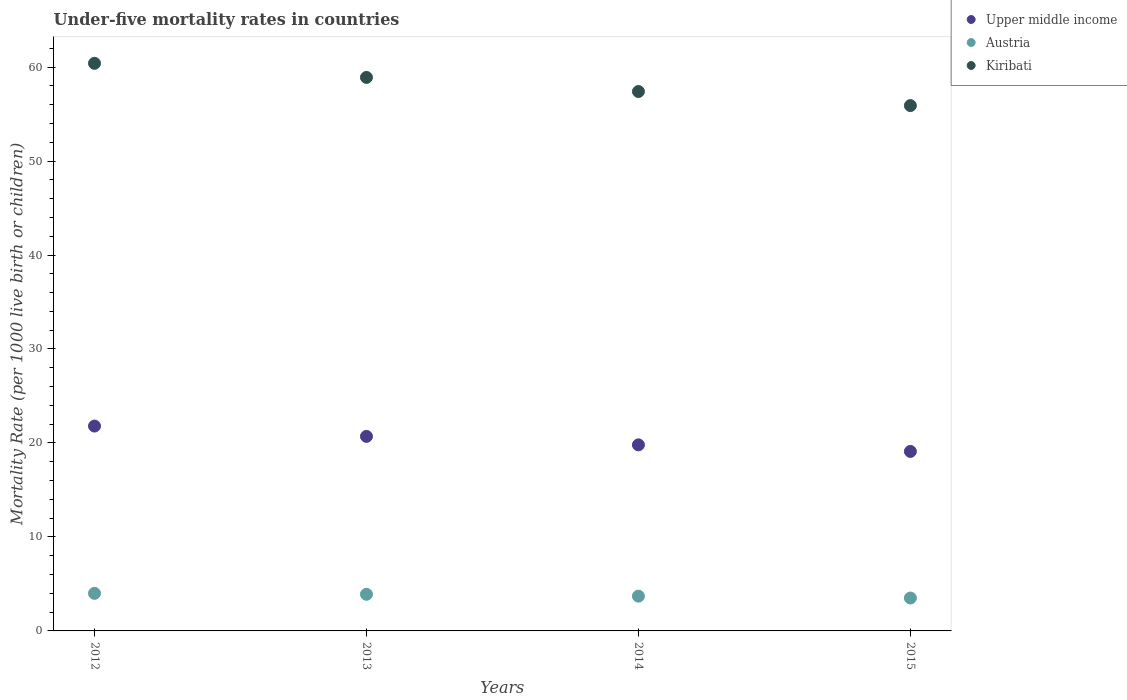How many different coloured dotlines are there?
Your answer should be very brief. 3. In which year was the under-five mortality rate in Kiribati maximum?
Provide a succinct answer. 2012. In which year was the under-five mortality rate in Austria minimum?
Your answer should be very brief. 2015. What is the total under-five mortality rate in Austria in the graph?
Your response must be concise. 15.1. What is the difference between the under-five mortality rate in Austria in 2013 and that in 2014?
Make the answer very short. 0.2. What is the difference between the under-five mortality rate in Austria in 2015 and the under-five mortality rate in Upper middle income in 2012?
Give a very brief answer. -18.3. What is the average under-five mortality rate in Upper middle income per year?
Your answer should be very brief. 20.35. In the year 2013, what is the difference between the under-five mortality rate in Upper middle income and under-five mortality rate in Kiribati?
Keep it short and to the point. -38.2. What is the ratio of the under-five mortality rate in Kiribati in 2013 to that in 2015?
Your answer should be very brief. 1.05. Is the difference between the under-five mortality rate in Upper middle income in 2014 and 2015 greater than the difference between the under-five mortality rate in Kiribati in 2014 and 2015?
Offer a very short reply. No. What is the difference between the highest and the second highest under-five mortality rate in Upper middle income?
Your response must be concise. 1.1. What is the difference between the highest and the lowest under-five mortality rate in Kiribati?
Your response must be concise. 4.5. Is the sum of the under-five mortality rate in Austria in 2014 and 2015 greater than the maximum under-five mortality rate in Kiribati across all years?
Your answer should be very brief. No. Does the under-five mortality rate in Austria monotonically increase over the years?
Your answer should be very brief. No. How many dotlines are there?
Your answer should be very brief. 3. What is the difference between two consecutive major ticks on the Y-axis?
Provide a succinct answer. 10. Are the values on the major ticks of Y-axis written in scientific E-notation?
Offer a terse response. No. Does the graph contain grids?
Give a very brief answer. No. Where does the legend appear in the graph?
Your response must be concise. Top right. How many legend labels are there?
Your response must be concise. 3. How are the legend labels stacked?
Give a very brief answer. Vertical. What is the title of the graph?
Offer a terse response. Under-five mortality rates in countries. What is the label or title of the Y-axis?
Your response must be concise. Mortality Rate (per 1000 live birth or children). What is the Mortality Rate (per 1000 live birth or children) in Upper middle income in 2012?
Offer a very short reply. 21.8. What is the Mortality Rate (per 1000 live birth or children) in Austria in 2012?
Your answer should be compact. 4. What is the Mortality Rate (per 1000 live birth or children) of Kiribati in 2012?
Provide a short and direct response. 60.4. What is the Mortality Rate (per 1000 live birth or children) in Upper middle income in 2013?
Provide a short and direct response. 20.7. What is the Mortality Rate (per 1000 live birth or children) of Kiribati in 2013?
Offer a very short reply. 58.9. What is the Mortality Rate (per 1000 live birth or children) of Upper middle income in 2014?
Ensure brevity in your answer.  19.8. What is the Mortality Rate (per 1000 live birth or children) in Kiribati in 2014?
Your response must be concise. 57.4. What is the Mortality Rate (per 1000 live birth or children) in Upper middle income in 2015?
Your response must be concise. 19.1. What is the Mortality Rate (per 1000 live birth or children) of Austria in 2015?
Give a very brief answer. 3.5. What is the Mortality Rate (per 1000 live birth or children) of Kiribati in 2015?
Offer a terse response. 55.9. Across all years, what is the maximum Mortality Rate (per 1000 live birth or children) in Upper middle income?
Keep it short and to the point. 21.8. Across all years, what is the maximum Mortality Rate (per 1000 live birth or children) of Austria?
Keep it short and to the point. 4. Across all years, what is the maximum Mortality Rate (per 1000 live birth or children) of Kiribati?
Keep it short and to the point. 60.4. Across all years, what is the minimum Mortality Rate (per 1000 live birth or children) in Austria?
Offer a very short reply. 3.5. Across all years, what is the minimum Mortality Rate (per 1000 live birth or children) in Kiribati?
Your answer should be compact. 55.9. What is the total Mortality Rate (per 1000 live birth or children) in Upper middle income in the graph?
Keep it short and to the point. 81.4. What is the total Mortality Rate (per 1000 live birth or children) of Kiribati in the graph?
Offer a terse response. 232.6. What is the difference between the Mortality Rate (per 1000 live birth or children) in Austria in 2012 and that in 2013?
Provide a succinct answer. 0.1. What is the difference between the Mortality Rate (per 1000 live birth or children) in Kiribati in 2012 and that in 2013?
Your answer should be very brief. 1.5. What is the difference between the Mortality Rate (per 1000 live birth or children) of Upper middle income in 2012 and that in 2014?
Your answer should be very brief. 2. What is the difference between the Mortality Rate (per 1000 live birth or children) in Austria in 2012 and that in 2014?
Provide a short and direct response. 0.3. What is the difference between the Mortality Rate (per 1000 live birth or children) of Kiribati in 2012 and that in 2014?
Ensure brevity in your answer.  3. What is the difference between the Mortality Rate (per 1000 live birth or children) of Upper middle income in 2012 and that in 2015?
Keep it short and to the point. 2.7. What is the difference between the Mortality Rate (per 1000 live birth or children) in Upper middle income in 2013 and that in 2014?
Provide a short and direct response. 0.9. What is the difference between the Mortality Rate (per 1000 live birth or children) in Austria in 2013 and that in 2014?
Make the answer very short. 0.2. What is the difference between the Mortality Rate (per 1000 live birth or children) of Upper middle income in 2013 and that in 2015?
Your answer should be very brief. 1.6. What is the difference between the Mortality Rate (per 1000 live birth or children) in Upper middle income in 2012 and the Mortality Rate (per 1000 live birth or children) in Kiribati in 2013?
Ensure brevity in your answer.  -37.1. What is the difference between the Mortality Rate (per 1000 live birth or children) of Austria in 2012 and the Mortality Rate (per 1000 live birth or children) of Kiribati in 2013?
Your answer should be compact. -54.9. What is the difference between the Mortality Rate (per 1000 live birth or children) in Upper middle income in 2012 and the Mortality Rate (per 1000 live birth or children) in Austria in 2014?
Provide a succinct answer. 18.1. What is the difference between the Mortality Rate (per 1000 live birth or children) of Upper middle income in 2012 and the Mortality Rate (per 1000 live birth or children) of Kiribati in 2014?
Give a very brief answer. -35.6. What is the difference between the Mortality Rate (per 1000 live birth or children) in Austria in 2012 and the Mortality Rate (per 1000 live birth or children) in Kiribati in 2014?
Your answer should be compact. -53.4. What is the difference between the Mortality Rate (per 1000 live birth or children) in Upper middle income in 2012 and the Mortality Rate (per 1000 live birth or children) in Kiribati in 2015?
Offer a very short reply. -34.1. What is the difference between the Mortality Rate (per 1000 live birth or children) in Austria in 2012 and the Mortality Rate (per 1000 live birth or children) in Kiribati in 2015?
Give a very brief answer. -51.9. What is the difference between the Mortality Rate (per 1000 live birth or children) in Upper middle income in 2013 and the Mortality Rate (per 1000 live birth or children) in Kiribati in 2014?
Provide a succinct answer. -36.7. What is the difference between the Mortality Rate (per 1000 live birth or children) in Austria in 2013 and the Mortality Rate (per 1000 live birth or children) in Kiribati in 2014?
Your answer should be very brief. -53.5. What is the difference between the Mortality Rate (per 1000 live birth or children) in Upper middle income in 2013 and the Mortality Rate (per 1000 live birth or children) in Kiribati in 2015?
Keep it short and to the point. -35.2. What is the difference between the Mortality Rate (per 1000 live birth or children) in Austria in 2013 and the Mortality Rate (per 1000 live birth or children) in Kiribati in 2015?
Your answer should be compact. -52. What is the difference between the Mortality Rate (per 1000 live birth or children) of Upper middle income in 2014 and the Mortality Rate (per 1000 live birth or children) of Austria in 2015?
Ensure brevity in your answer.  16.3. What is the difference between the Mortality Rate (per 1000 live birth or children) of Upper middle income in 2014 and the Mortality Rate (per 1000 live birth or children) of Kiribati in 2015?
Keep it short and to the point. -36.1. What is the difference between the Mortality Rate (per 1000 live birth or children) in Austria in 2014 and the Mortality Rate (per 1000 live birth or children) in Kiribati in 2015?
Make the answer very short. -52.2. What is the average Mortality Rate (per 1000 live birth or children) in Upper middle income per year?
Keep it short and to the point. 20.35. What is the average Mortality Rate (per 1000 live birth or children) of Austria per year?
Provide a short and direct response. 3.77. What is the average Mortality Rate (per 1000 live birth or children) in Kiribati per year?
Offer a terse response. 58.15. In the year 2012, what is the difference between the Mortality Rate (per 1000 live birth or children) of Upper middle income and Mortality Rate (per 1000 live birth or children) of Austria?
Your answer should be compact. 17.8. In the year 2012, what is the difference between the Mortality Rate (per 1000 live birth or children) of Upper middle income and Mortality Rate (per 1000 live birth or children) of Kiribati?
Your response must be concise. -38.6. In the year 2012, what is the difference between the Mortality Rate (per 1000 live birth or children) of Austria and Mortality Rate (per 1000 live birth or children) of Kiribati?
Provide a short and direct response. -56.4. In the year 2013, what is the difference between the Mortality Rate (per 1000 live birth or children) of Upper middle income and Mortality Rate (per 1000 live birth or children) of Austria?
Keep it short and to the point. 16.8. In the year 2013, what is the difference between the Mortality Rate (per 1000 live birth or children) in Upper middle income and Mortality Rate (per 1000 live birth or children) in Kiribati?
Provide a short and direct response. -38.2. In the year 2013, what is the difference between the Mortality Rate (per 1000 live birth or children) of Austria and Mortality Rate (per 1000 live birth or children) of Kiribati?
Your answer should be very brief. -55. In the year 2014, what is the difference between the Mortality Rate (per 1000 live birth or children) of Upper middle income and Mortality Rate (per 1000 live birth or children) of Kiribati?
Your answer should be compact. -37.6. In the year 2014, what is the difference between the Mortality Rate (per 1000 live birth or children) in Austria and Mortality Rate (per 1000 live birth or children) in Kiribati?
Your answer should be compact. -53.7. In the year 2015, what is the difference between the Mortality Rate (per 1000 live birth or children) in Upper middle income and Mortality Rate (per 1000 live birth or children) in Kiribati?
Make the answer very short. -36.8. In the year 2015, what is the difference between the Mortality Rate (per 1000 live birth or children) of Austria and Mortality Rate (per 1000 live birth or children) of Kiribati?
Offer a very short reply. -52.4. What is the ratio of the Mortality Rate (per 1000 live birth or children) in Upper middle income in 2012 to that in 2013?
Keep it short and to the point. 1.05. What is the ratio of the Mortality Rate (per 1000 live birth or children) of Austria in 2012 to that in 2013?
Give a very brief answer. 1.03. What is the ratio of the Mortality Rate (per 1000 live birth or children) of Kiribati in 2012 to that in 2013?
Your answer should be very brief. 1.03. What is the ratio of the Mortality Rate (per 1000 live birth or children) of Upper middle income in 2012 to that in 2014?
Your answer should be very brief. 1.1. What is the ratio of the Mortality Rate (per 1000 live birth or children) in Austria in 2012 to that in 2014?
Ensure brevity in your answer.  1.08. What is the ratio of the Mortality Rate (per 1000 live birth or children) in Kiribati in 2012 to that in 2014?
Offer a very short reply. 1.05. What is the ratio of the Mortality Rate (per 1000 live birth or children) of Upper middle income in 2012 to that in 2015?
Offer a terse response. 1.14. What is the ratio of the Mortality Rate (per 1000 live birth or children) of Austria in 2012 to that in 2015?
Offer a terse response. 1.14. What is the ratio of the Mortality Rate (per 1000 live birth or children) in Kiribati in 2012 to that in 2015?
Give a very brief answer. 1.08. What is the ratio of the Mortality Rate (per 1000 live birth or children) of Upper middle income in 2013 to that in 2014?
Make the answer very short. 1.05. What is the ratio of the Mortality Rate (per 1000 live birth or children) in Austria in 2013 to that in 2014?
Provide a succinct answer. 1.05. What is the ratio of the Mortality Rate (per 1000 live birth or children) of Kiribati in 2013 to that in 2014?
Provide a succinct answer. 1.03. What is the ratio of the Mortality Rate (per 1000 live birth or children) of Upper middle income in 2013 to that in 2015?
Your response must be concise. 1.08. What is the ratio of the Mortality Rate (per 1000 live birth or children) of Austria in 2013 to that in 2015?
Offer a terse response. 1.11. What is the ratio of the Mortality Rate (per 1000 live birth or children) of Kiribati in 2013 to that in 2015?
Offer a terse response. 1.05. What is the ratio of the Mortality Rate (per 1000 live birth or children) in Upper middle income in 2014 to that in 2015?
Offer a terse response. 1.04. What is the ratio of the Mortality Rate (per 1000 live birth or children) in Austria in 2014 to that in 2015?
Offer a very short reply. 1.06. What is the ratio of the Mortality Rate (per 1000 live birth or children) in Kiribati in 2014 to that in 2015?
Provide a succinct answer. 1.03. What is the difference between the highest and the lowest Mortality Rate (per 1000 live birth or children) of Upper middle income?
Ensure brevity in your answer.  2.7. What is the difference between the highest and the lowest Mortality Rate (per 1000 live birth or children) in Kiribati?
Make the answer very short. 4.5. 